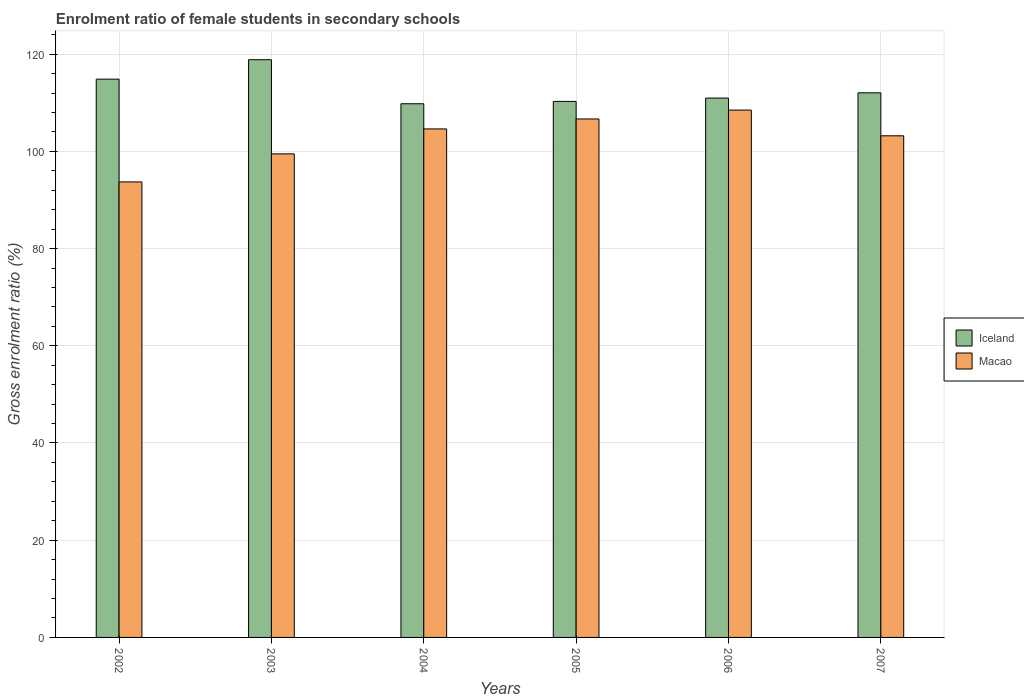How many different coloured bars are there?
Offer a terse response. 2. Are the number of bars per tick equal to the number of legend labels?
Offer a terse response. Yes. How many bars are there on the 4th tick from the left?
Your response must be concise. 2. What is the enrolment ratio of female students in secondary schools in Macao in 2002?
Provide a short and direct response. 93.71. Across all years, what is the maximum enrolment ratio of female students in secondary schools in Macao?
Make the answer very short. 108.49. Across all years, what is the minimum enrolment ratio of female students in secondary schools in Iceland?
Provide a succinct answer. 109.79. In which year was the enrolment ratio of female students in secondary schools in Macao maximum?
Your answer should be very brief. 2006. What is the total enrolment ratio of female students in secondary schools in Iceland in the graph?
Provide a succinct answer. 676.79. What is the difference between the enrolment ratio of female students in secondary schools in Macao in 2002 and that in 2004?
Ensure brevity in your answer.  -10.9. What is the difference between the enrolment ratio of female students in secondary schools in Macao in 2006 and the enrolment ratio of female students in secondary schools in Iceland in 2002?
Your answer should be compact. -6.37. What is the average enrolment ratio of female students in secondary schools in Macao per year?
Offer a very short reply. 102.69. In the year 2005, what is the difference between the enrolment ratio of female students in secondary schools in Macao and enrolment ratio of female students in secondary schools in Iceland?
Ensure brevity in your answer.  -3.61. What is the ratio of the enrolment ratio of female students in secondary schools in Iceland in 2002 to that in 2007?
Offer a very short reply. 1.03. Is the enrolment ratio of female students in secondary schools in Macao in 2002 less than that in 2005?
Make the answer very short. Yes. Is the difference between the enrolment ratio of female students in secondary schools in Macao in 2003 and 2006 greater than the difference between the enrolment ratio of female students in secondary schools in Iceland in 2003 and 2006?
Provide a short and direct response. No. What is the difference between the highest and the second highest enrolment ratio of female students in secondary schools in Macao?
Provide a succinct answer. 1.83. What is the difference between the highest and the lowest enrolment ratio of female students in secondary schools in Macao?
Ensure brevity in your answer.  14.78. In how many years, is the enrolment ratio of female students in secondary schools in Macao greater than the average enrolment ratio of female students in secondary schools in Macao taken over all years?
Your answer should be compact. 4. Is the sum of the enrolment ratio of female students in secondary schools in Macao in 2002 and 2006 greater than the maximum enrolment ratio of female students in secondary schools in Iceland across all years?
Provide a succinct answer. Yes. What does the 1st bar from the left in 2003 represents?
Ensure brevity in your answer.  Iceland. Are all the bars in the graph horizontal?
Your response must be concise. No. What is the difference between two consecutive major ticks on the Y-axis?
Provide a succinct answer. 20. Does the graph contain grids?
Keep it short and to the point. Yes. Where does the legend appear in the graph?
Provide a succinct answer. Center right. How many legend labels are there?
Keep it short and to the point. 2. What is the title of the graph?
Provide a short and direct response. Enrolment ratio of female students in secondary schools. What is the Gross enrolment ratio (%) of Iceland in 2002?
Give a very brief answer. 114.86. What is the Gross enrolment ratio (%) of Macao in 2002?
Your answer should be very brief. 93.71. What is the Gross enrolment ratio (%) of Iceland in 2003?
Your answer should be compact. 118.85. What is the Gross enrolment ratio (%) in Macao in 2003?
Ensure brevity in your answer.  99.48. What is the Gross enrolment ratio (%) of Iceland in 2004?
Ensure brevity in your answer.  109.79. What is the Gross enrolment ratio (%) in Macao in 2004?
Your response must be concise. 104.61. What is the Gross enrolment ratio (%) in Iceland in 2005?
Make the answer very short. 110.28. What is the Gross enrolment ratio (%) in Macao in 2005?
Ensure brevity in your answer.  106.66. What is the Gross enrolment ratio (%) of Iceland in 2006?
Make the answer very short. 110.97. What is the Gross enrolment ratio (%) in Macao in 2006?
Offer a very short reply. 108.49. What is the Gross enrolment ratio (%) of Iceland in 2007?
Offer a very short reply. 112.04. What is the Gross enrolment ratio (%) of Macao in 2007?
Keep it short and to the point. 103.2. Across all years, what is the maximum Gross enrolment ratio (%) in Iceland?
Your response must be concise. 118.85. Across all years, what is the maximum Gross enrolment ratio (%) of Macao?
Offer a terse response. 108.49. Across all years, what is the minimum Gross enrolment ratio (%) in Iceland?
Offer a terse response. 109.79. Across all years, what is the minimum Gross enrolment ratio (%) in Macao?
Your response must be concise. 93.71. What is the total Gross enrolment ratio (%) of Iceland in the graph?
Your answer should be compact. 676.79. What is the total Gross enrolment ratio (%) of Macao in the graph?
Your response must be concise. 616.16. What is the difference between the Gross enrolment ratio (%) in Iceland in 2002 and that in 2003?
Offer a terse response. -3.99. What is the difference between the Gross enrolment ratio (%) of Macao in 2002 and that in 2003?
Provide a succinct answer. -5.77. What is the difference between the Gross enrolment ratio (%) of Iceland in 2002 and that in 2004?
Give a very brief answer. 5.07. What is the difference between the Gross enrolment ratio (%) in Macao in 2002 and that in 2004?
Make the answer very short. -10.9. What is the difference between the Gross enrolment ratio (%) in Iceland in 2002 and that in 2005?
Your response must be concise. 4.58. What is the difference between the Gross enrolment ratio (%) of Macao in 2002 and that in 2005?
Make the answer very short. -12.95. What is the difference between the Gross enrolment ratio (%) in Iceland in 2002 and that in 2006?
Give a very brief answer. 3.89. What is the difference between the Gross enrolment ratio (%) in Macao in 2002 and that in 2006?
Provide a succinct answer. -14.78. What is the difference between the Gross enrolment ratio (%) of Iceland in 2002 and that in 2007?
Your answer should be compact. 2.82. What is the difference between the Gross enrolment ratio (%) in Macao in 2002 and that in 2007?
Make the answer very short. -9.49. What is the difference between the Gross enrolment ratio (%) in Iceland in 2003 and that in 2004?
Offer a terse response. 9.06. What is the difference between the Gross enrolment ratio (%) in Macao in 2003 and that in 2004?
Ensure brevity in your answer.  -5.13. What is the difference between the Gross enrolment ratio (%) in Iceland in 2003 and that in 2005?
Offer a very short reply. 8.58. What is the difference between the Gross enrolment ratio (%) in Macao in 2003 and that in 2005?
Provide a succinct answer. -7.18. What is the difference between the Gross enrolment ratio (%) of Iceland in 2003 and that in 2006?
Offer a terse response. 7.89. What is the difference between the Gross enrolment ratio (%) in Macao in 2003 and that in 2006?
Keep it short and to the point. -9.01. What is the difference between the Gross enrolment ratio (%) of Iceland in 2003 and that in 2007?
Offer a terse response. 6.81. What is the difference between the Gross enrolment ratio (%) in Macao in 2003 and that in 2007?
Keep it short and to the point. -3.72. What is the difference between the Gross enrolment ratio (%) in Iceland in 2004 and that in 2005?
Provide a succinct answer. -0.48. What is the difference between the Gross enrolment ratio (%) of Macao in 2004 and that in 2005?
Your answer should be compact. -2.05. What is the difference between the Gross enrolment ratio (%) of Iceland in 2004 and that in 2006?
Provide a succinct answer. -1.17. What is the difference between the Gross enrolment ratio (%) of Macao in 2004 and that in 2006?
Provide a succinct answer. -3.88. What is the difference between the Gross enrolment ratio (%) in Iceland in 2004 and that in 2007?
Offer a terse response. -2.25. What is the difference between the Gross enrolment ratio (%) in Macao in 2004 and that in 2007?
Keep it short and to the point. 1.41. What is the difference between the Gross enrolment ratio (%) in Iceland in 2005 and that in 2006?
Provide a succinct answer. -0.69. What is the difference between the Gross enrolment ratio (%) in Macao in 2005 and that in 2006?
Your response must be concise. -1.83. What is the difference between the Gross enrolment ratio (%) of Iceland in 2005 and that in 2007?
Your response must be concise. -1.77. What is the difference between the Gross enrolment ratio (%) in Macao in 2005 and that in 2007?
Your response must be concise. 3.46. What is the difference between the Gross enrolment ratio (%) in Iceland in 2006 and that in 2007?
Your answer should be compact. -1.08. What is the difference between the Gross enrolment ratio (%) in Macao in 2006 and that in 2007?
Provide a short and direct response. 5.29. What is the difference between the Gross enrolment ratio (%) of Iceland in 2002 and the Gross enrolment ratio (%) of Macao in 2003?
Give a very brief answer. 15.38. What is the difference between the Gross enrolment ratio (%) in Iceland in 2002 and the Gross enrolment ratio (%) in Macao in 2004?
Offer a very short reply. 10.24. What is the difference between the Gross enrolment ratio (%) in Iceland in 2002 and the Gross enrolment ratio (%) in Macao in 2005?
Your answer should be very brief. 8.2. What is the difference between the Gross enrolment ratio (%) of Iceland in 2002 and the Gross enrolment ratio (%) of Macao in 2006?
Ensure brevity in your answer.  6.37. What is the difference between the Gross enrolment ratio (%) in Iceland in 2002 and the Gross enrolment ratio (%) in Macao in 2007?
Ensure brevity in your answer.  11.66. What is the difference between the Gross enrolment ratio (%) of Iceland in 2003 and the Gross enrolment ratio (%) of Macao in 2004?
Provide a succinct answer. 14.24. What is the difference between the Gross enrolment ratio (%) of Iceland in 2003 and the Gross enrolment ratio (%) of Macao in 2005?
Your answer should be very brief. 12.19. What is the difference between the Gross enrolment ratio (%) in Iceland in 2003 and the Gross enrolment ratio (%) in Macao in 2006?
Your answer should be compact. 10.36. What is the difference between the Gross enrolment ratio (%) in Iceland in 2003 and the Gross enrolment ratio (%) in Macao in 2007?
Your answer should be very brief. 15.65. What is the difference between the Gross enrolment ratio (%) of Iceland in 2004 and the Gross enrolment ratio (%) of Macao in 2005?
Ensure brevity in your answer.  3.13. What is the difference between the Gross enrolment ratio (%) in Iceland in 2004 and the Gross enrolment ratio (%) in Macao in 2006?
Give a very brief answer. 1.3. What is the difference between the Gross enrolment ratio (%) in Iceland in 2004 and the Gross enrolment ratio (%) in Macao in 2007?
Keep it short and to the point. 6.59. What is the difference between the Gross enrolment ratio (%) in Iceland in 2005 and the Gross enrolment ratio (%) in Macao in 2006?
Keep it short and to the point. 1.78. What is the difference between the Gross enrolment ratio (%) in Iceland in 2005 and the Gross enrolment ratio (%) in Macao in 2007?
Make the answer very short. 7.08. What is the difference between the Gross enrolment ratio (%) in Iceland in 2006 and the Gross enrolment ratio (%) in Macao in 2007?
Provide a short and direct response. 7.77. What is the average Gross enrolment ratio (%) in Iceland per year?
Ensure brevity in your answer.  112.8. What is the average Gross enrolment ratio (%) of Macao per year?
Provide a succinct answer. 102.69. In the year 2002, what is the difference between the Gross enrolment ratio (%) of Iceland and Gross enrolment ratio (%) of Macao?
Provide a succinct answer. 21.15. In the year 2003, what is the difference between the Gross enrolment ratio (%) of Iceland and Gross enrolment ratio (%) of Macao?
Provide a short and direct response. 19.37. In the year 2004, what is the difference between the Gross enrolment ratio (%) in Iceland and Gross enrolment ratio (%) in Macao?
Ensure brevity in your answer.  5.18. In the year 2005, what is the difference between the Gross enrolment ratio (%) in Iceland and Gross enrolment ratio (%) in Macao?
Provide a short and direct response. 3.61. In the year 2006, what is the difference between the Gross enrolment ratio (%) in Iceland and Gross enrolment ratio (%) in Macao?
Give a very brief answer. 2.47. In the year 2007, what is the difference between the Gross enrolment ratio (%) in Iceland and Gross enrolment ratio (%) in Macao?
Your answer should be compact. 8.84. What is the ratio of the Gross enrolment ratio (%) of Iceland in 2002 to that in 2003?
Give a very brief answer. 0.97. What is the ratio of the Gross enrolment ratio (%) of Macao in 2002 to that in 2003?
Your answer should be compact. 0.94. What is the ratio of the Gross enrolment ratio (%) of Iceland in 2002 to that in 2004?
Ensure brevity in your answer.  1.05. What is the ratio of the Gross enrolment ratio (%) in Macao in 2002 to that in 2004?
Keep it short and to the point. 0.9. What is the ratio of the Gross enrolment ratio (%) of Iceland in 2002 to that in 2005?
Provide a succinct answer. 1.04. What is the ratio of the Gross enrolment ratio (%) in Macao in 2002 to that in 2005?
Ensure brevity in your answer.  0.88. What is the ratio of the Gross enrolment ratio (%) in Iceland in 2002 to that in 2006?
Ensure brevity in your answer.  1.04. What is the ratio of the Gross enrolment ratio (%) of Macao in 2002 to that in 2006?
Provide a short and direct response. 0.86. What is the ratio of the Gross enrolment ratio (%) in Iceland in 2002 to that in 2007?
Your answer should be very brief. 1.03. What is the ratio of the Gross enrolment ratio (%) of Macao in 2002 to that in 2007?
Provide a short and direct response. 0.91. What is the ratio of the Gross enrolment ratio (%) in Iceland in 2003 to that in 2004?
Your answer should be very brief. 1.08. What is the ratio of the Gross enrolment ratio (%) of Macao in 2003 to that in 2004?
Provide a succinct answer. 0.95. What is the ratio of the Gross enrolment ratio (%) of Iceland in 2003 to that in 2005?
Ensure brevity in your answer.  1.08. What is the ratio of the Gross enrolment ratio (%) of Macao in 2003 to that in 2005?
Provide a short and direct response. 0.93. What is the ratio of the Gross enrolment ratio (%) of Iceland in 2003 to that in 2006?
Your response must be concise. 1.07. What is the ratio of the Gross enrolment ratio (%) of Macao in 2003 to that in 2006?
Make the answer very short. 0.92. What is the ratio of the Gross enrolment ratio (%) in Iceland in 2003 to that in 2007?
Offer a terse response. 1.06. What is the ratio of the Gross enrolment ratio (%) in Iceland in 2004 to that in 2005?
Provide a succinct answer. 1. What is the ratio of the Gross enrolment ratio (%) in Macao in 2004 to that in 2005?
Your answer should be very brief. 0.98. What is the ratio of the Gross enrolment ratio (%) in Iceland in 2004 to that in 2006?
Your answer should be compact. 0.99. What is the ratio of the Gross enrolment ratio (%) in Macao in 2004 to that in 2006?
Give a very brief answer. 0.96. What is the ratio of the Gross enrolment ratio (%) in Iceland in 2004 to that in 2007?
Your response must be concise. 0.98. What is the ratio of the Gross enrolment ratio (%) of Macao in 2004 to that in 2007?
Provide a short and direct response. 1.01. What is the ratio of the Gross enrolment ratio (%) of Iceland in 2005 to that in 2006?
Offer a very short reply. 0.99. What is the ratio of the Gross enrolment ratio (%) in Macao in 2005 to that in 2006?
Your answer should be compact. 0.98. What is the ratio of the Gross enrolment ratio (%) of Iceland in 2005 to that in 2007?
Ensure brevity in your answer.  0.98. What is the ratio of the Gross enrolment ratio (%) in Macao in 2005 to that in 2007?
Your answer should be very brief. 1.03. What is the ratio of the Gross enrolment ratio (%) of Macao in 2006 to that in 2007?
Provide a short and direct response. 1.05. What is the difference between the highest and the second highest Gross enrolment ratio (%) in Iceland?
Ensure brevity in your answer.  3.99. What is the difference between the highest and the second highest Gross enrolment ratio (%) in Macao?
Keep it short and to the point. 1.83. What is the difference between the highest and the lowest Gross enrolment ratio (%) in Iceland?
Offer a terse response. 9.06. What is the difference between the highest and the lowest Gross enrolment ratio (%) in Macao?
Provide a succinct answer. 14.78. 